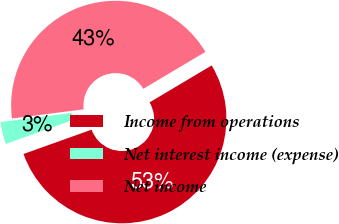Convert chart. <chart><loc_0><loc_0><loc_500><loc_500><pie_chart><fcel>Income from operations<fcel>Net interest income (expense)<fcel>Net income<nl><fcel>53.08%<fcel>3.44%<fcel>43.49%<nl></chart> 